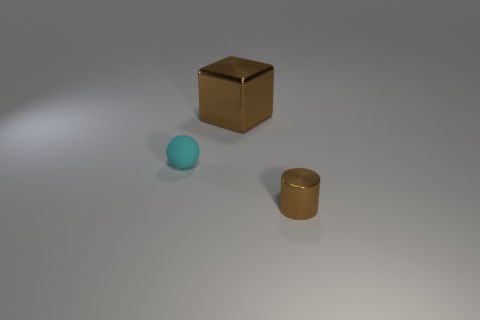There is a cylinder; what number of tiny brown metallic cylinders are on the left side of it?
Ensure brevity in your answer.  0. How big is the object that is right of the tiny cyan matte sphere and to the left of the cylinder?
Your answer should be very brief. Large. Are there any small cyan things?
Ensure brevity in your answer.  Yes. What number of other objects are the same size as the cyan rubber ball?
Make the answer very short. 1. There is a small object that is behind the cylinder; is its color the same as the metal thing that is behind the cylinder?
Your answer should be very brief. No. Do the small thing behind the tiny shiny cylinder and the small thing to the right of the tiny matte object have the same material?
Ensure brevity in your answer.  No. What number of metal objects are tiny balls or tiny blue blocks?
Provide a short and direct response. 0. What is the material of the brown thing that is left of the brown thing that is on the right side of the metallic thing to the left of the tiny shiny cylinder?
Your answer should be compact. Metal. Do the brown thing that is behind the tiny brown object and the thing that is in front of the small sphere have the same shape?
Your answer should be compact. No. There is a metallic object that is to the right of the brown metallic thing left of the small metal cylinder; what is its color?
Give a very brief answer. Brown. 